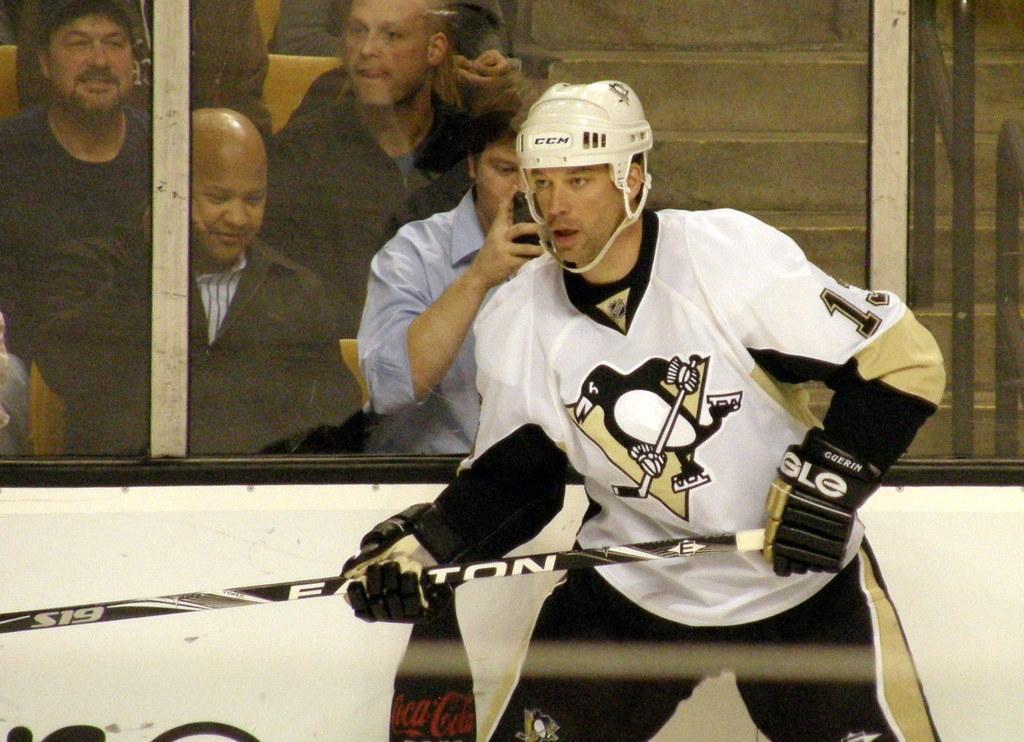Can you describe this image briefly? This man wore a helmet and holding a bat. Through this glass windows we can see people and steps. This man is holding a mobile. 